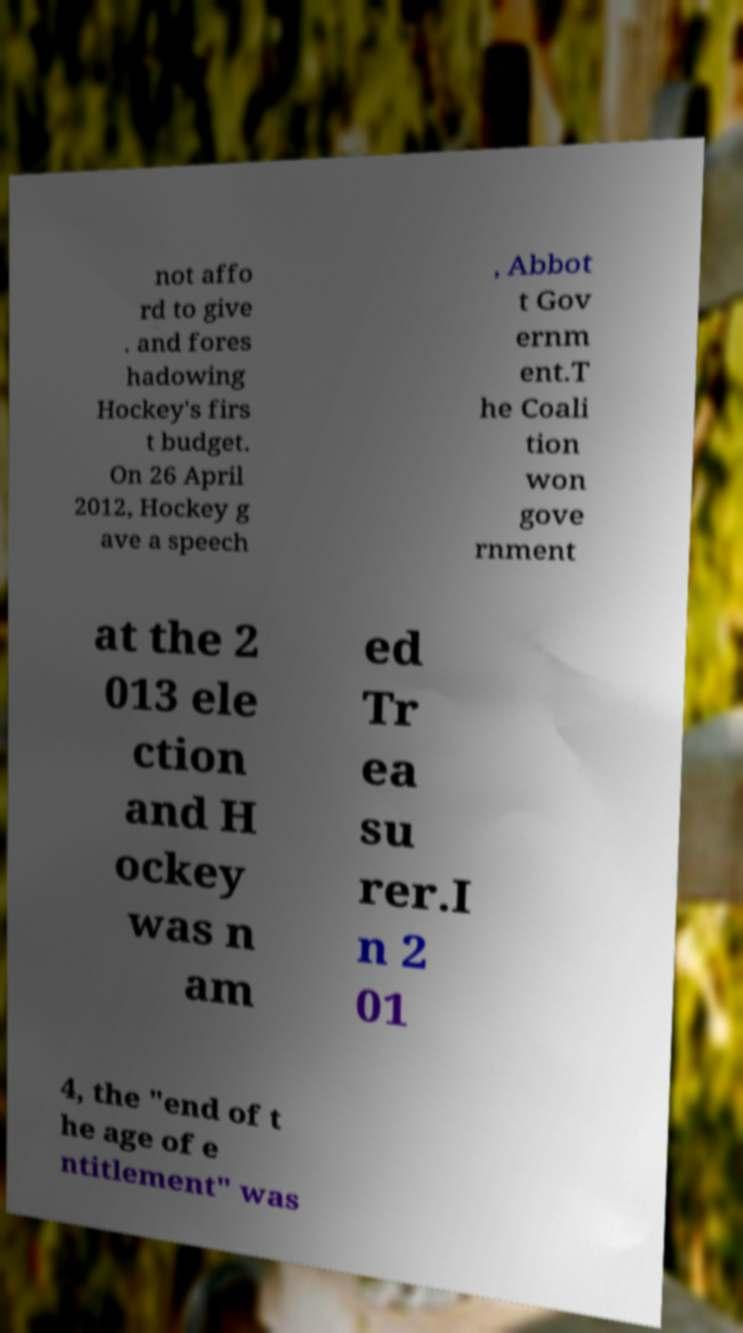Please read and relay the text visible in this image. What does it say? not affo rd to give . and fores hadowing Hockey's firs t budget. On 26 April 2012, Hockey g ave a speech , Abbot t Gov ernm ent.T he Coali tion won gove rnment at the 2 013 ele ction and H ockey was n am ed Tr ea su rer.I n 2 01 4, the "end of t he age of e ntitlement" was 